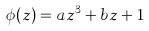<formula> <loc_0><loc_0><loc_500><loc_500>\phi ( z ) = a z ^ { 3 } + b z + 1</formula> 